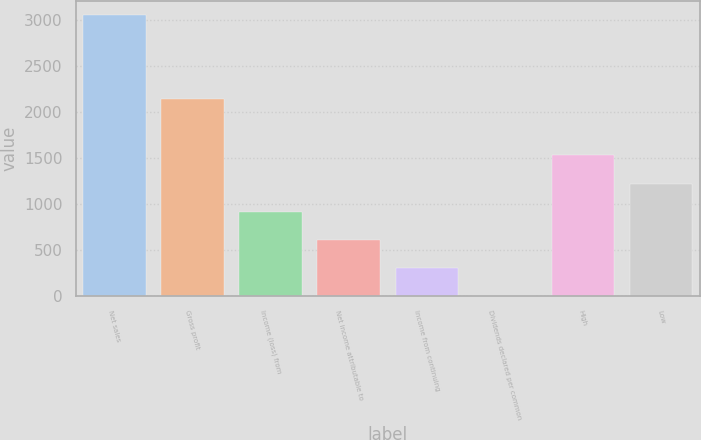<chart> <loc_0><loc_0><loc_500><loc_500><bar_chart><fcel>Net sales<fcel>Gross profit<fcel>Income (loss) from<fcel>Net income attributable to<fcel>Income from continuing<fcel>Dividends declared per common<fcel>High<fcel>Low<nl><fcel>3054.9<fcel>2138.48<fcel>916.6<fcel>611.13<fcel>305.66<fcel>0.19<fcel>1527.54<fcel>1222.07<nl></chart> 